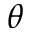<formula> <loc_0><loc_0><loc_500><loc_500>\theta</formula> 